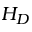Convert formula to latex. <formula><loc_0><loc_0><loc_500><loc_500>H _ { D }</formula> 